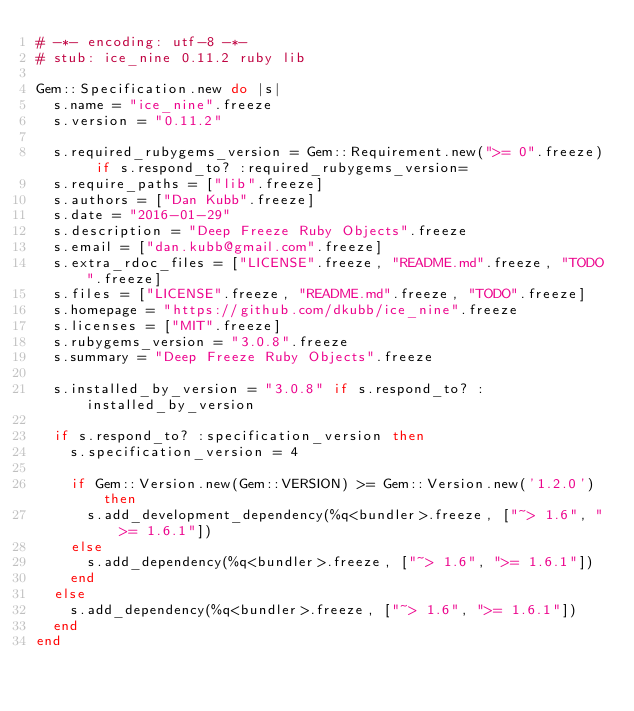<code> <loc_0><loc_0><loc_500><loc_500><_Ruby_># -*- encoding: utf-8 -*-
# stub: ice_nine 0.11.2 ruby lib

Gem::Specification.new do |s|
  s.name = "ice_nine".freeze
  s.version = "0.11.2"

  s.required_rubygems_version = Gem::Requirement.new(">= 0".freeze) if s.respond_to? :required_rubygems_version=
  s.require_paths = ["lib".freeze]
  s.authors = ["Dan Kubb".freeze]
  s.date = "2016-01-29"
  s.description = "Deep Freeze Ruby Objects".freeze
  s.email = ["dan.kubb@gmail.com".freeze]
  s.extra_rdoc_files = ["LICENSE".freeze, "README.md".freeze, "TODO".freeze]
  s.files = ["LICENSE".freeze, "README.md".freeze, "TODO".freeze]
  s.homepage = "https://github.com/dkubb/ice_nine".freeze
  s.licenses = ["MIT".freeze]
  s.rubygems_version = "3.0.8".freeze
  s.summary = "Deep Freeze Ruby Objects".freeze

  s.installed_by_version = "3.0.8" if s.respond_to? :installed_by_version

  if s.respond_to? :specification_version then
    s.specification_version = 4

    if Gem::Version.new(Gem::VERSION) >= Gem::Version.new('1.2.0') then
      s.add_development_dependency(%q<bundler>.freeze, ["~> 1.6", ">= 1.6.1"])
    else
      s.add_dependency(%q<bundler>.freeze, ["~> 1.6", ">= 1.6.1"])
    end
  else
    s.add_dependency(%q<bundler>.freeze, ["~> 1.6", ">= 1.6.1"])
  end
end
</code> 